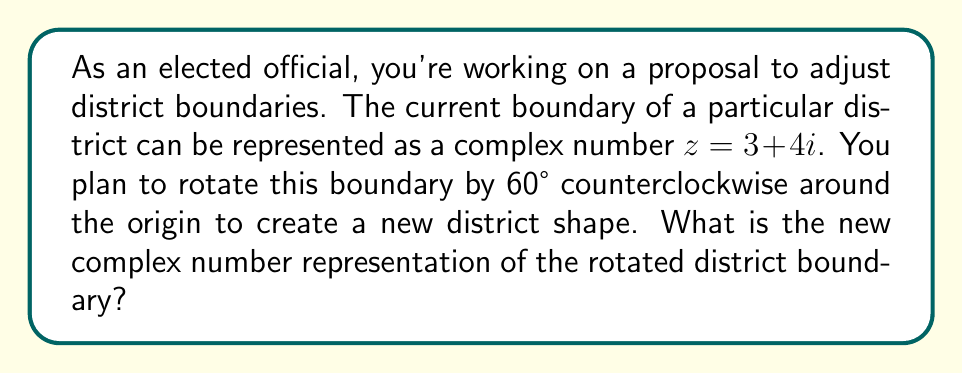Can you solve this math problem? To solve this problem, we'll use the properties of complex number rotation. When we rotate a complex number $z$ by an angle $\theta$ counterclockwise around the origin, we multiply it by $e^{i\theta}$, where $i$ is the imaginary unit.

1) First, let's recall Euler's formula: $e^{i\theta} = \cos\theta + i\sin\theta$

2) In this case, $\theta = 60°$. We need to convert this to radians:
   $60° = \frac{\pi}{3}$ radians

3) Now, we can calculate $e^{i\theta}$:
   $e^{i\frac{\pi}{3}} = \cos\frac{\pi}{3} + i\sin\frac{\pi}{3} = \frac{1}{2} + i\frac{\sqrt{3}}{2}$

4) The original complex number is $z = 3 + 4i$

5) To rotate, we multiply $z$ by $e^{i\frac{\pi}{3}}$:
   $z_{new} = z \cdot e^{i\frac{\pi}{3}} = (3 + 4i)(\frac{1}{2} + i\frac{\sqrt{3}}{2})$

6) Let's multiply these complex numbers:
   $z_{new} = (3 \cdot \frac{1}{2} - 4 \cdot \frac{\sqrt{3}}{2}) + i(3 \cdot \frac{\sqrt{3}}{2} + 4 \cdot \frac{1}{2})$

7) Simplifying:
   $z_{new} = (\frac{3}{2} - 2\sqrt{3}) + i(\frac{3\sqrt{3}}{2} + 2)$

This complex number represents the new rotated district boundary.
Answer: $z_{new} = (\frac{3}{2} - 2\sqrt{3}) + i(\frac{3\sqrt{3}}{2} + 2)$ 